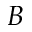<formula> <loc_0><loc_0><loc_500><loc_500>B</formula> 